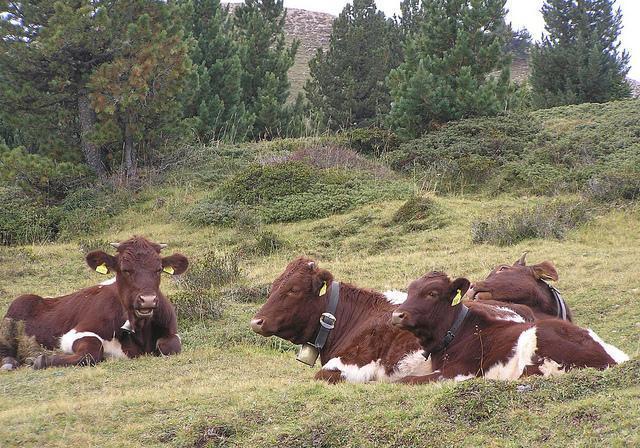How many cows are there?
Give a very brief answer. 4. How many tracks have a train on them?
Give a very brief answer. 0. 